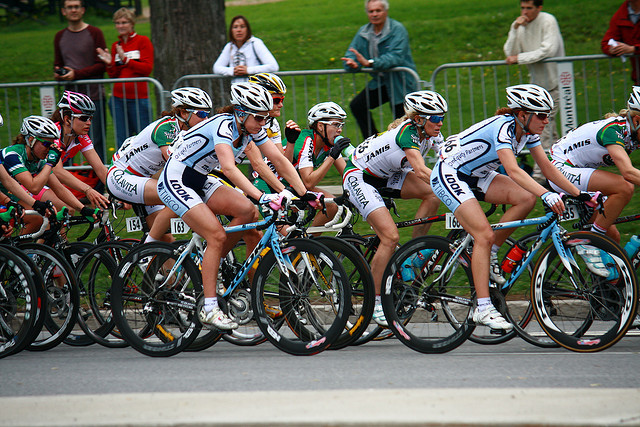Please extract the text content from this image. JAMIS LOOK TIBCO 154 LOOK 